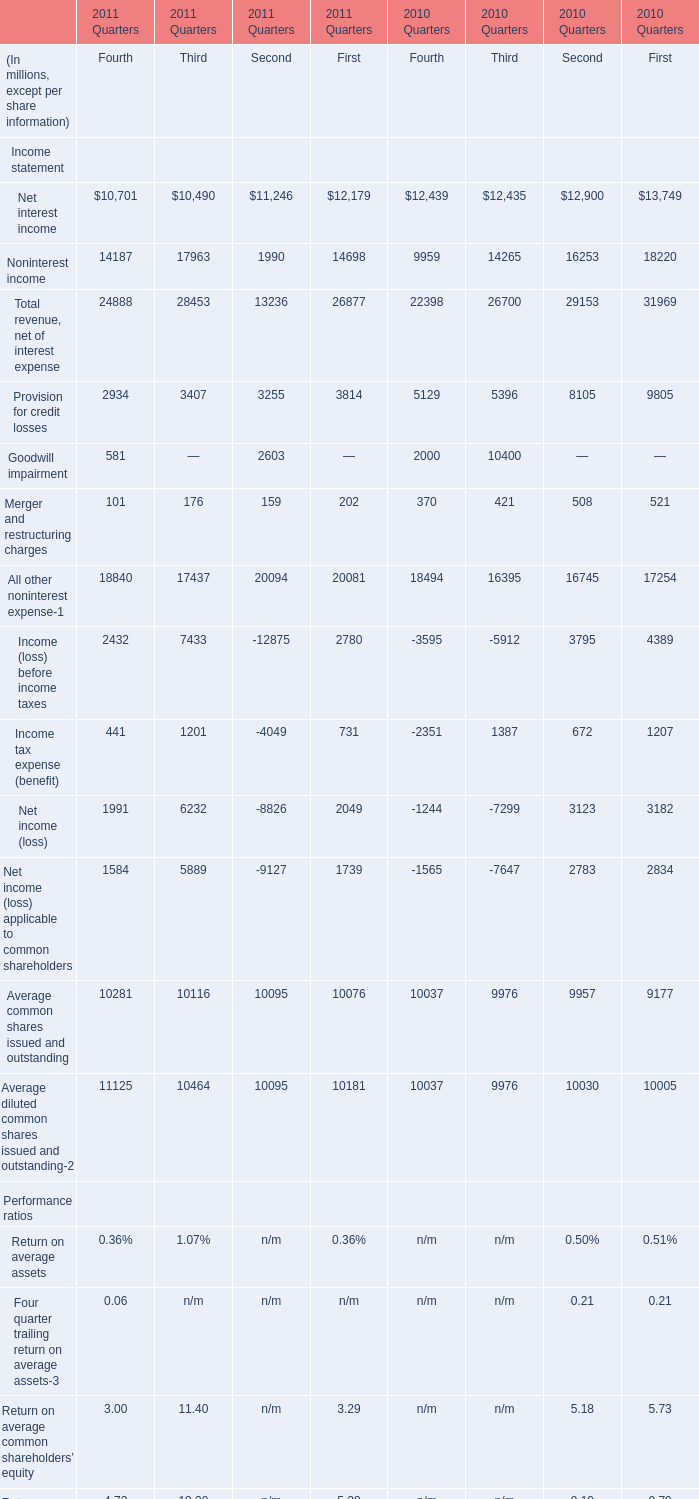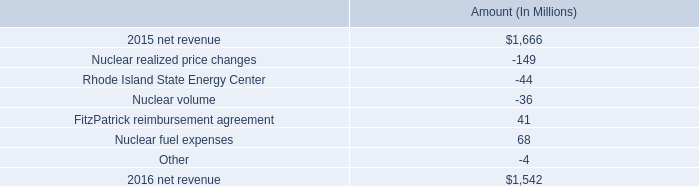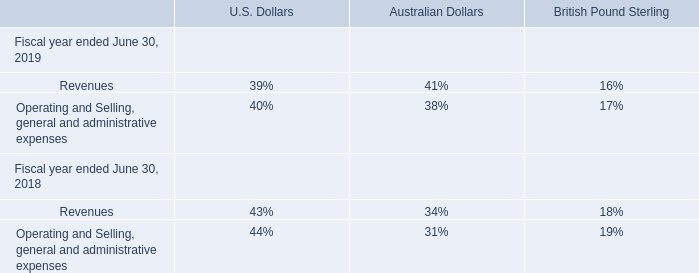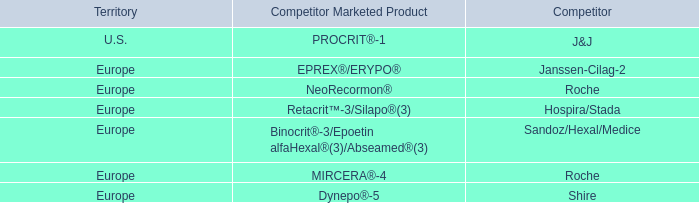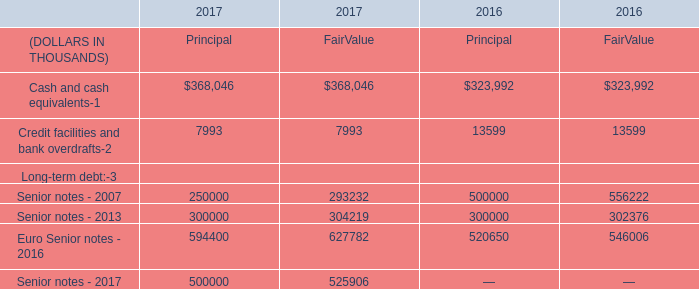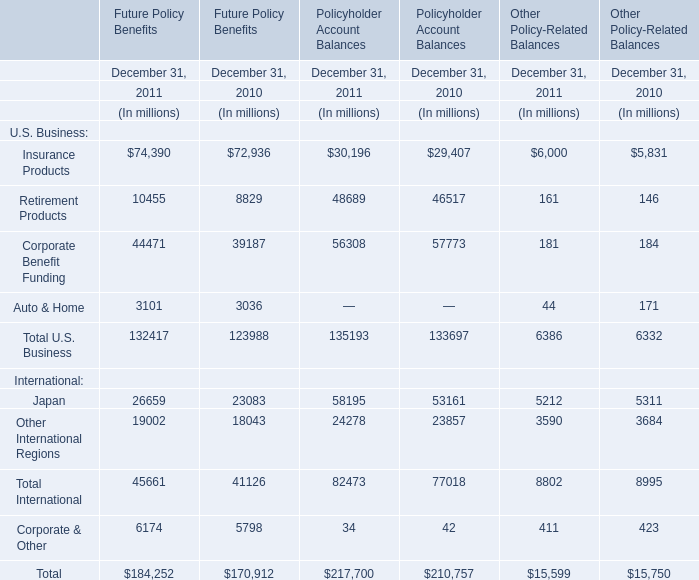what is the percent change in net revenue from 2015 to 2016? 
Computations: ((1666 - 1542) / 1542)
Answer: 0.08042. 